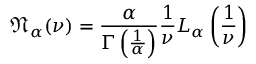<formula> <loc_0><loc_0><loc_500><loc_500>{ \mathfrak { N } } _ { \alpha } ( \nu ) = { \frac { \alpha } { \Gamma \left ( { \frac { 1 } { \alpha } } \right ) } } { \frac { 1 } { \nu } } L _ { \alpha } \left ( { \frac { 1 } { \nu } } \right )</formula> 